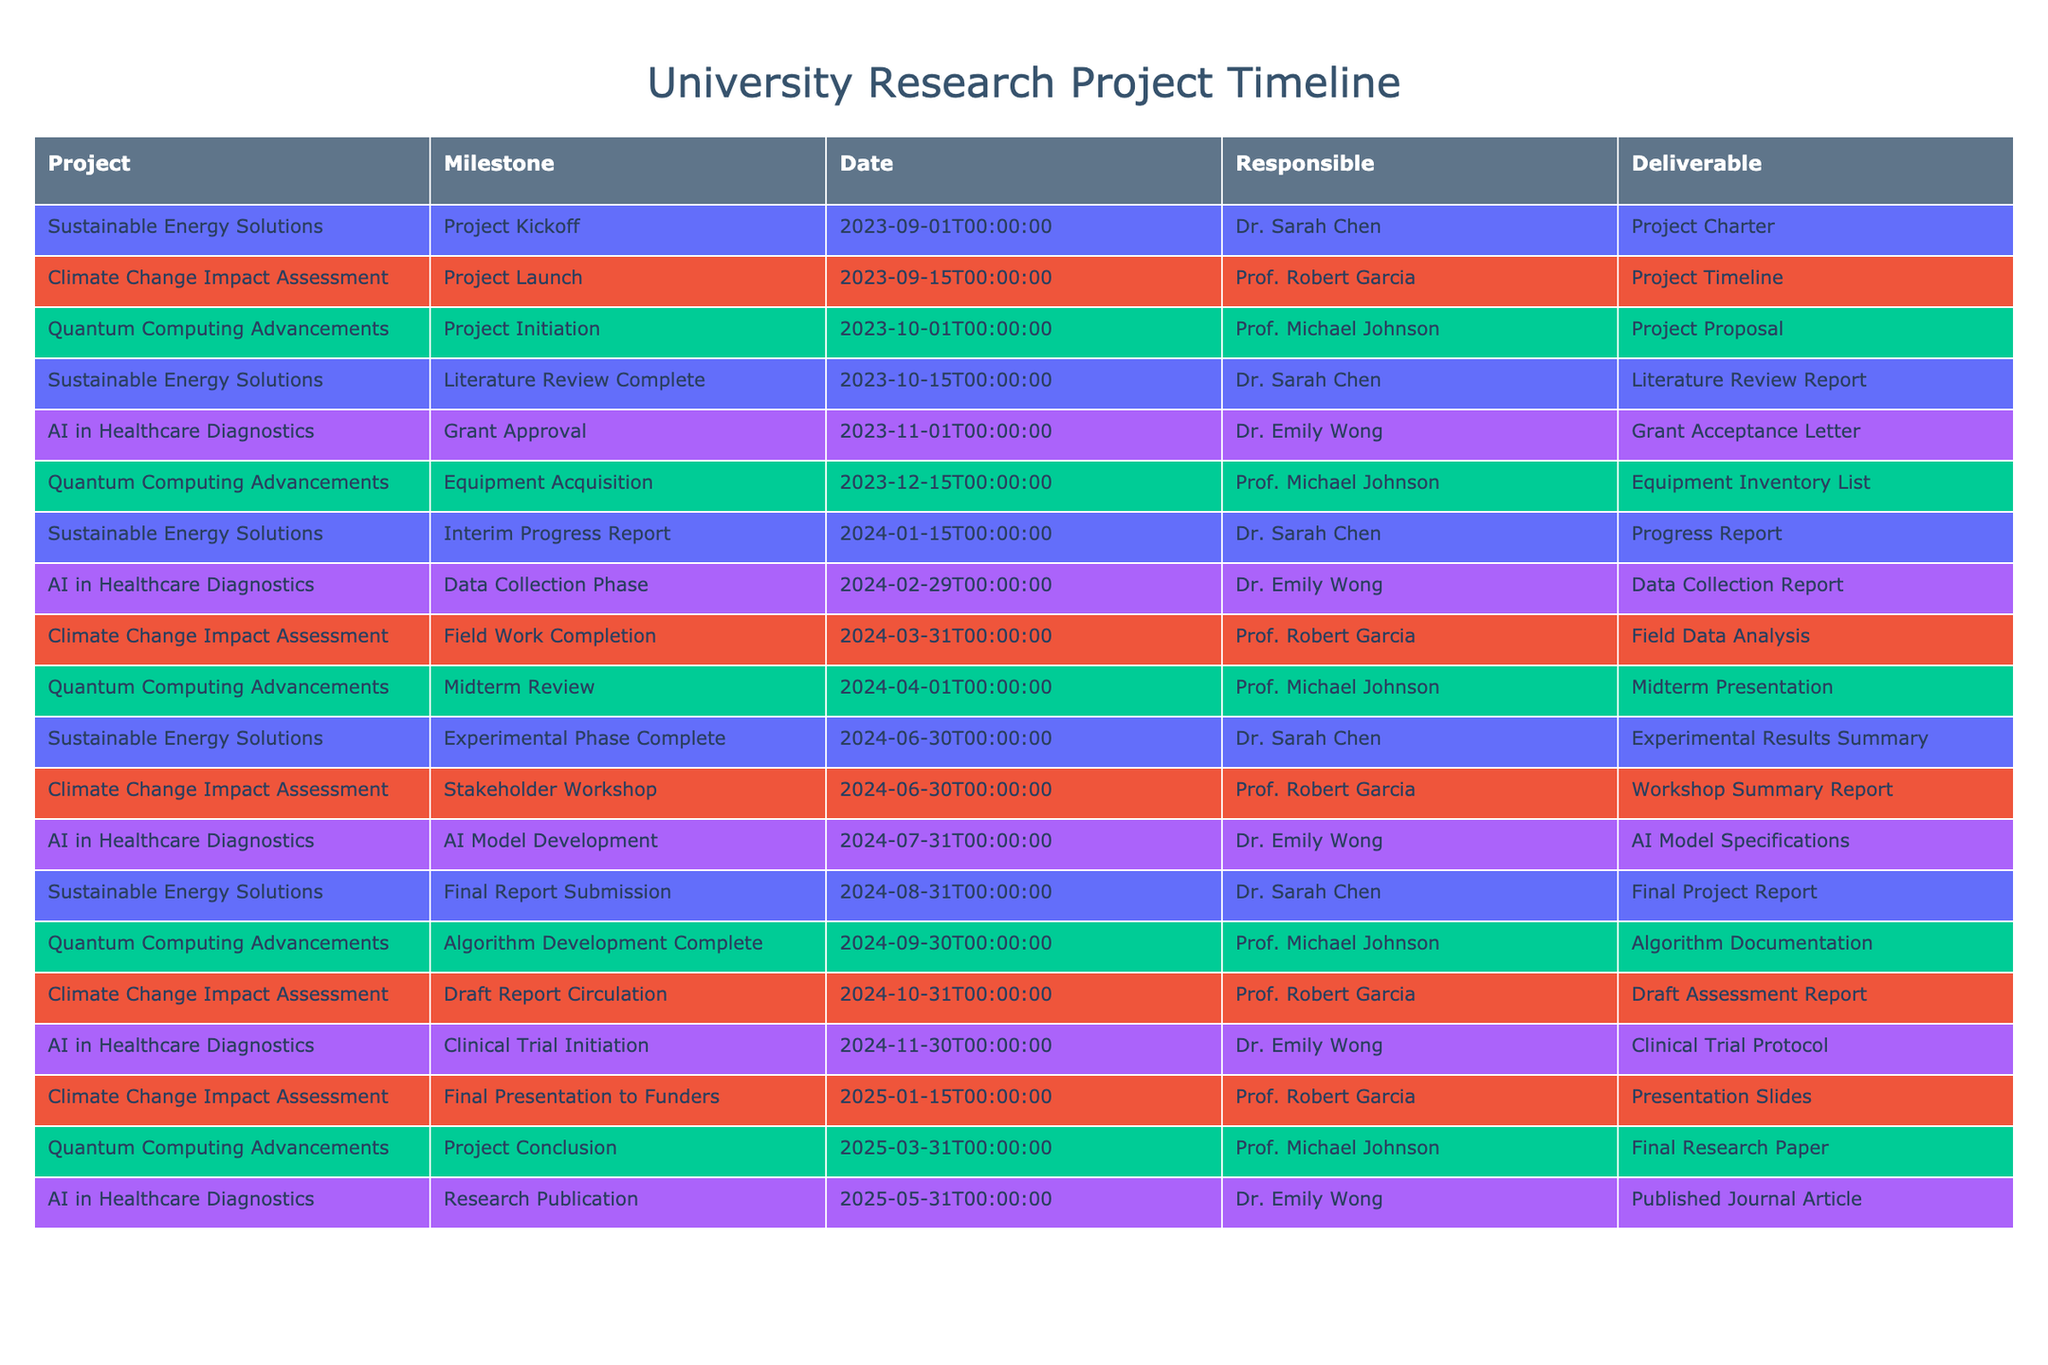What is the deliverable for the "Final Report Submission" milestone of the "Sustainable Energy Solutions" project? In the table, I locate the row with the "Sustainable Energy Solutions" project and find the milestone labeled "Final Report Submission." The corresponding deliverable for this milestone is "Final Project Report."
Answer: Final Project Report Which researcher is responsible for the "Midterm Review" of the "Quantum Computing Advancements" project? I look for the "Midterm Review" milestone in the "Quantum Computing Advancements" project. The responsible researcher listed in that row is "Prof. Michael Johnson."
Answer: Prof. Michael Johnson Is there a grant approval for the "AI in Healthcare Diagnostics" project before the data collection phase? Checking the timeline, the "Grant Approval" milestone for the "AI in Healthcare Diagnostics" project is dated 2023-11-01, which is before the "Data Collection Phase" dated 2024-02-29. Since the grant approval comes before the data collection phase, the answer is yes.
Answer: Yes What is the total number of milestones for the "Climate Change Impact Assessment" project? I count the milestones listed under the "Climate Change Impact Assessment" project: Project Launch, Field Work Completion, Stakeholder Workshop, Draft Report Circulation, and Final Presentation to Funders. This totals to 5 milestones.
Answer: 5 Which project has the earliest milestone date and what is the milestone? I examine the table for the earliest date across all projects. The earliest milestone date is 2023-09-01 for the "Project Kickoff" in the "Sustainable Energy Solutions" project.
Answer: Sustainable Energy Solutions, Project Kickoff What percentage of milestones in the "AI in Healthcare Diagnostics" project occur after 2024-06-30? The milestones for this project include "Grant Approval," "Data Collection Phase," "AI Model Development," "Clinical Trial Initiation," and "Research Publication." Three milestones ("Clinical Trial Initiation" and "Research Publication") fall after 2024-06-30 out of a total of 5 milestones. The percentage is (3/5) * 100 = 60%.
Answer: 60% How many different universities are represented in the timeline data? The table indicates there are four unique projects led by different researchers. Each researcher represents their respective university's collaboration. Since there are no repeat entries, I conclude that there are at least four distinct university contributions, but beyond that, I cannot determine from the provided data. Thus, I have to answer that I cannot be absolutely certain of how many universities are represented based solely on the data provided.
Answer: Indeterminate Is there an interim progress report for any project due in January 2024? The milestone list shows that the "Interim Progress Report" for the "Sustainable Energy Solutions" project is scheduled for January 15, 2024. Therefore, there is an interim progress report due in January 2024.
Answer: Yes 